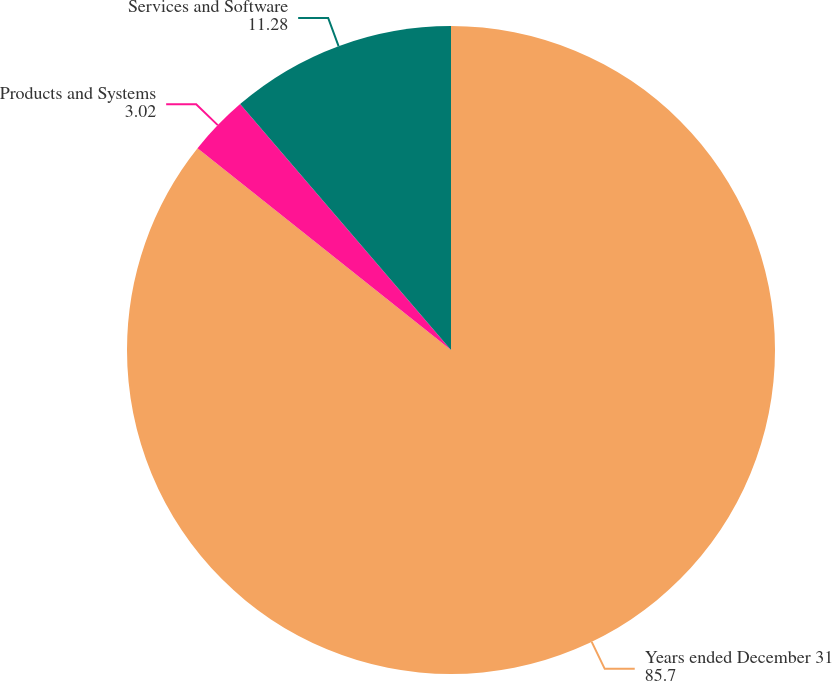<chart> <loc_0><loc_0><loc_500><loc_500><pie_chart><fcel>Years ended December 31<fcel>Products and Systems<fcel>Services and Software<nl><fcel>85.7%<fcel>3.02%<fcel>11.28%<nl></chart> 